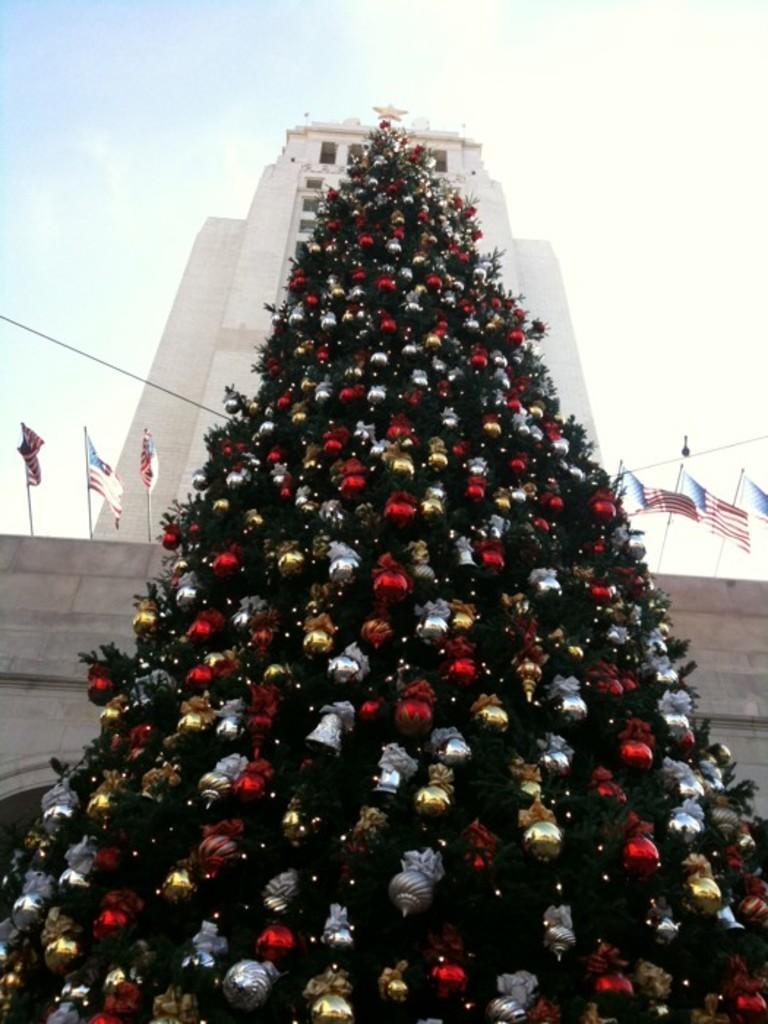Please provide a concise description of this image. In this image there is a Christmas tree, behind the Christmas tree there are flags on the building. 